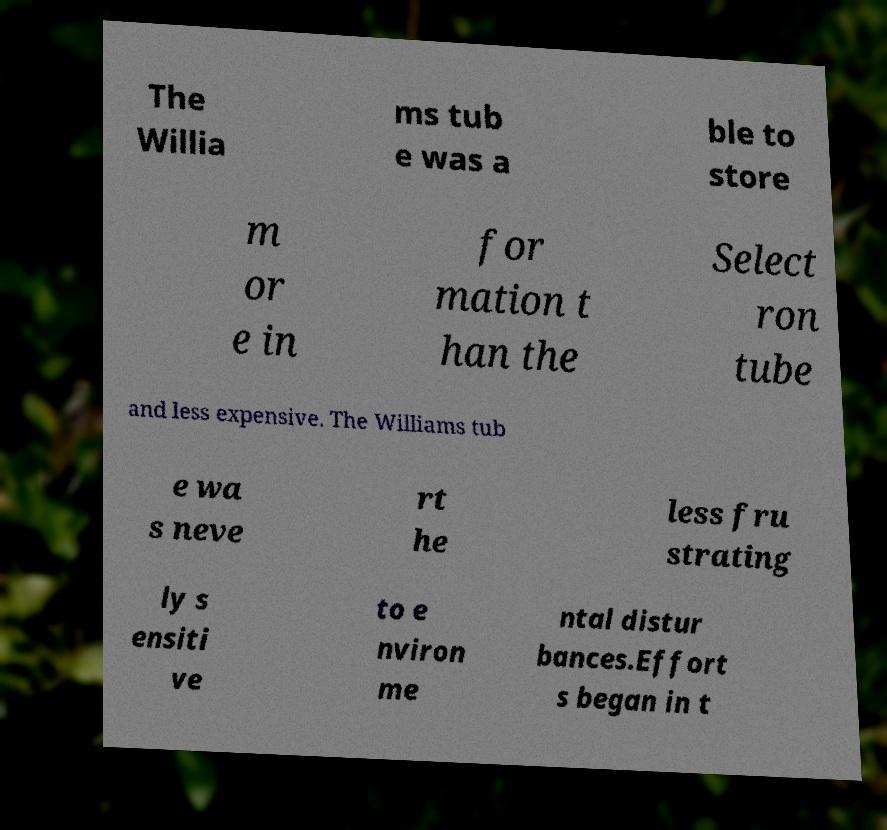There's text embedded in this image that I need extracted. Can you transcribe it verbatim? The Willia ms tub e was a ble to store m or e in for mation t han the Select ron tube and less expensive. The Williams tub e wa s neve rt he less fru strating ly s ensiti ve to e nviron me ntal distur bances.Effort s began in t 